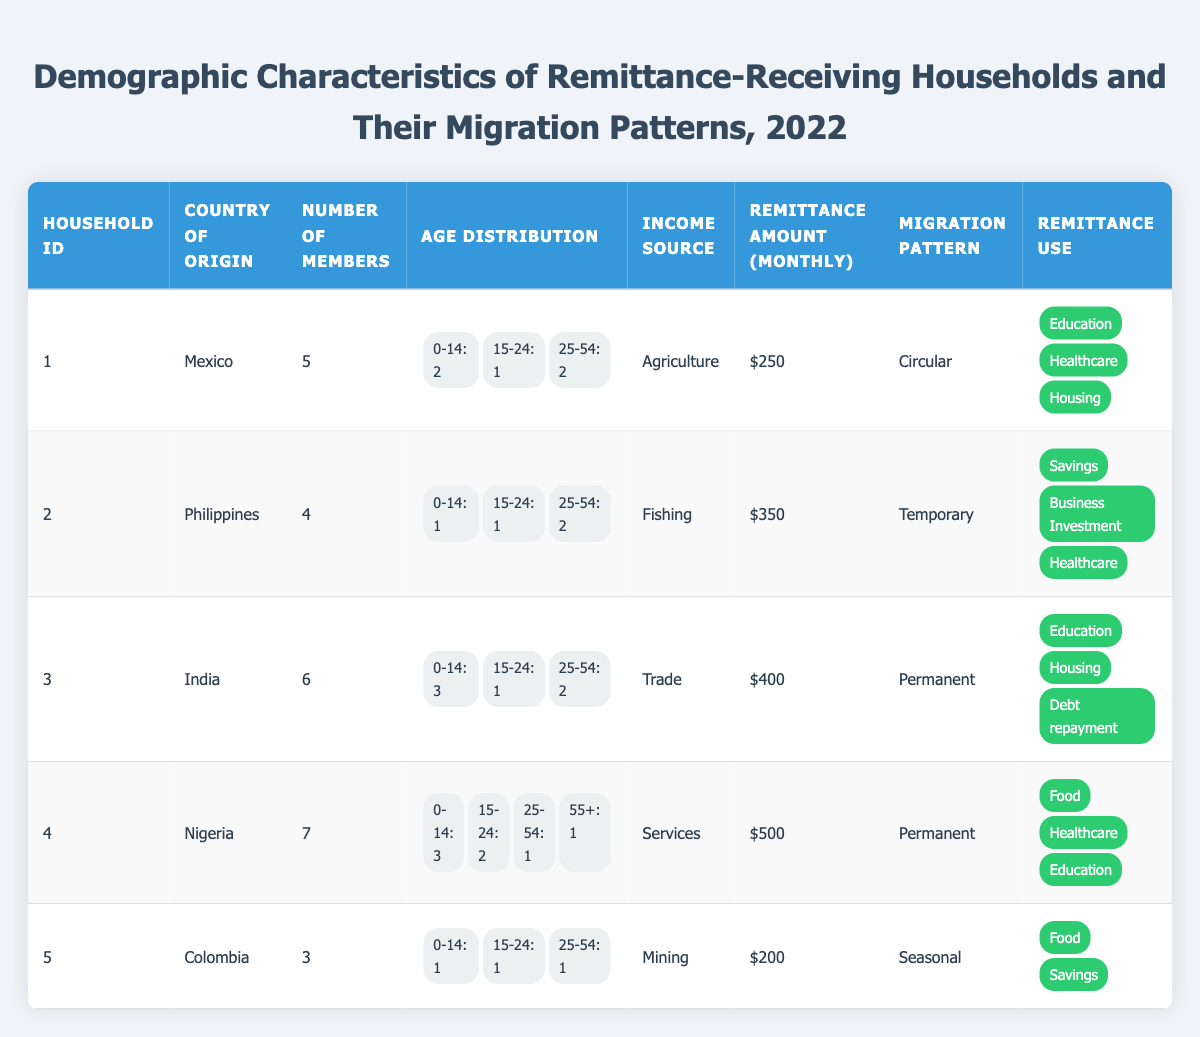What is the remittance amount per month for the household from Nigeria? From the table, we can see that household ID 4, which is from Nigeria, has a remittance amount of $500 per month listed under the "Remittance Amount (Monthly)" column.
Answer: $500 How many members are in the household from the Philippines? By looking at household ID 2, which is listed under the "Country of Origin" column as the Philippines, we find that the "Number of Members" value is 4.
Answer: 4 Which household has the highest remittance amount per month? The remittance amounts are $250 for Mexico, $350 for the Philippines, $400 for India, $500 for Nigeria, and $200 for Colombia. The highest among these is $500 for Nigeria (household ID 4).
Answer: Nigeria Is there any household that has children aged 0-14? Yes, the households from Mexico, India, Nigeria, and Colombia all have at least one member aged 0-14 as indicated in their respective age distributions.
Answer: Yes What is the average number of household members for all listed households? The number of members for each household is 5 (Mexico), 4 (Philippines), 6 (India), 7 (Nigeria), and 3 (Colombia). Adding these gives (5 + 4 + 6 + 7 + 3) = 25 members in total. There are 5 households, so the average number of members is 25/5 = 5.
Answer: 5 How many households have a migration pattern classified as "Permanent"? Referring to the table, household ID 3 (India) and household ID 4 (Nigeria) are marked with the migration pattern "Permanent," totaling 2 households.
Answer: 2 Which income source is associated with the household that receives the lowest remittance amount? The household that receives the lowest remittance amount is household ID 5 (Colombia) with $200. The associated income source for this household is "Mining."
Answer: Mining Which household has the greatest diversity in age distribution? Household ID 4 (Nigeria) shows diversity as it has members across 4 age groups: 0-14 (3), 15-24 (2), 25-54 (1), and 55+ (1), making it the household with the greatest diversity in age distribution.
Answer: Nigeria 